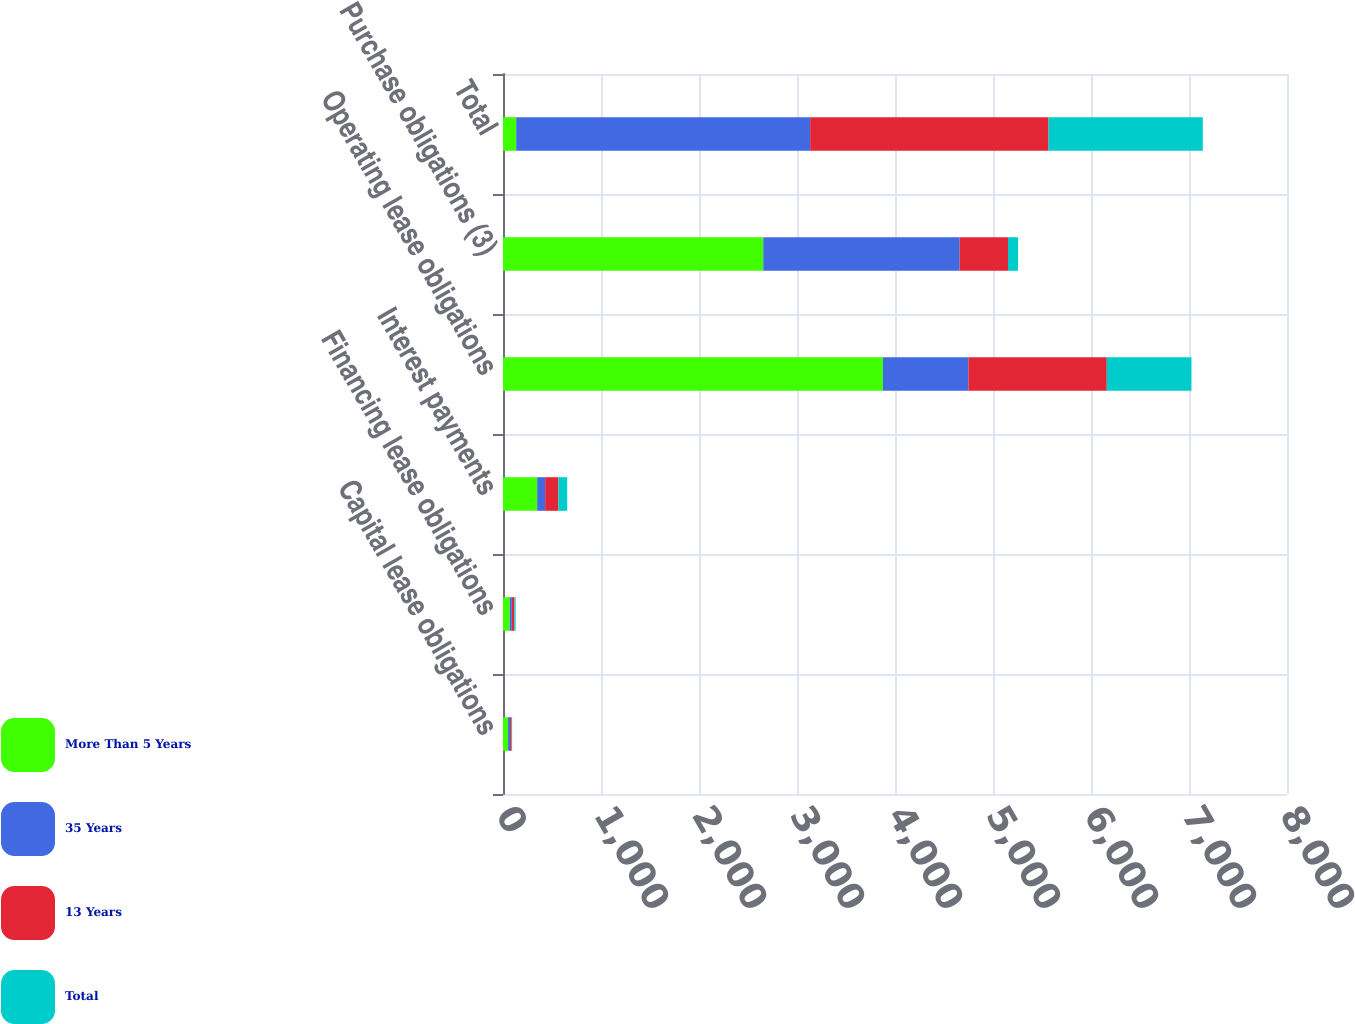<chart> <loc_0><loc_0><loc_500><loc_500><stacked_bar_chart><ecel><fcel>Capital lease obligations<fcel>Financing lease obligations<fcel>Interest payments<fcel>Operating lease obligations<fcel>Purchase obligations (3)<fcel>Total<nl><fcel>More Than 5 Years<fcel>52<fcel>69<fcel>349<fcel>3876<fcel>2656<fcel>135<nl><fcel>35 Years<fcel>20<fcel>21<fcel>81<fcel>873<fcel>2004<fcel>2999<nl><fcel>13 Years<fcel>16<fcel>27<fcel>135<fcel>1412<fcel>493<fcel>2433<nl><fcel>Total<fcel>5<fcel>12<fcel>90<fcel>864<fcel>103<fcel>1574<nl></chart> 